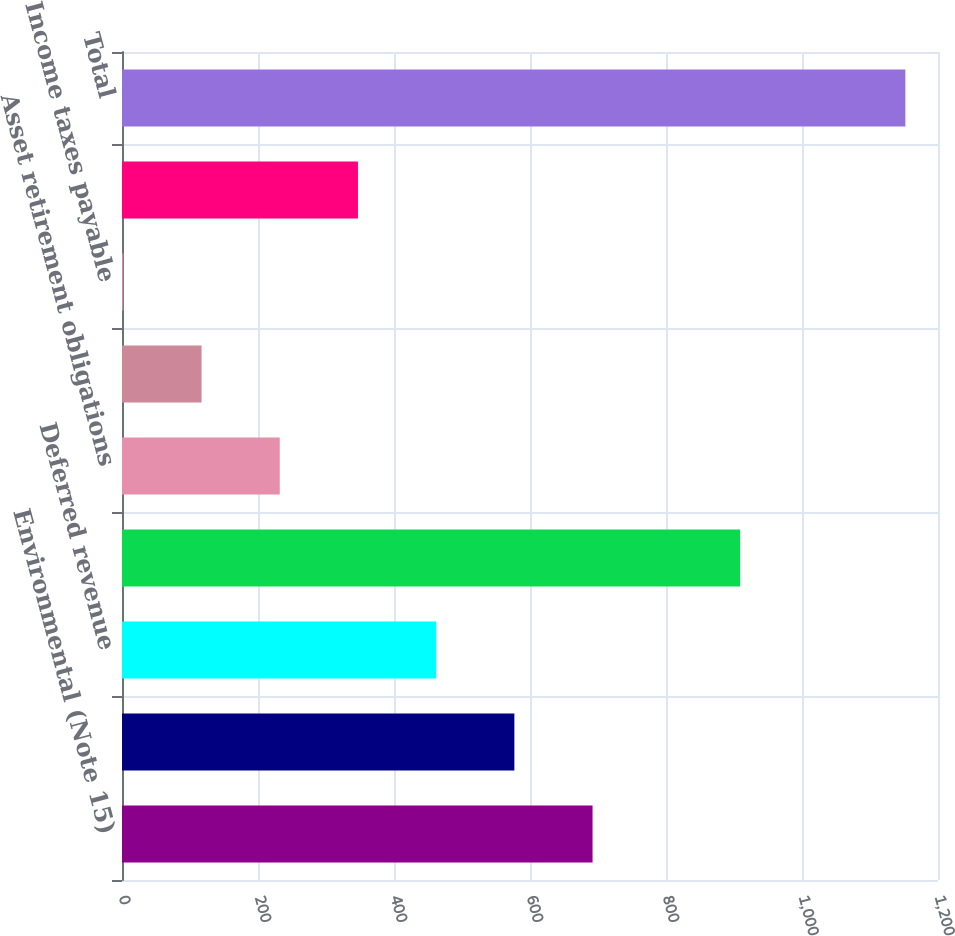Convert chart to OTSL. <chart><loc_0><loc_0><loc_500><loc_500><bar_chart><fcel>Environmental (Note 15)<fcel>Insurance<fcel>Deferred revenue<fcel>Deferred proceeds ^(1)<fcel>Asset retirement obligations<fcel>Derivatives (Note 21)<fcel>Income taxes payable<fcel>Other<fcel>Total<nl><fcel>692<fcel>577<fcel>462<fcel>909<fcel>232<fcel>117<fcel>2<fcel>347<fcel>1152<nl></chart> 